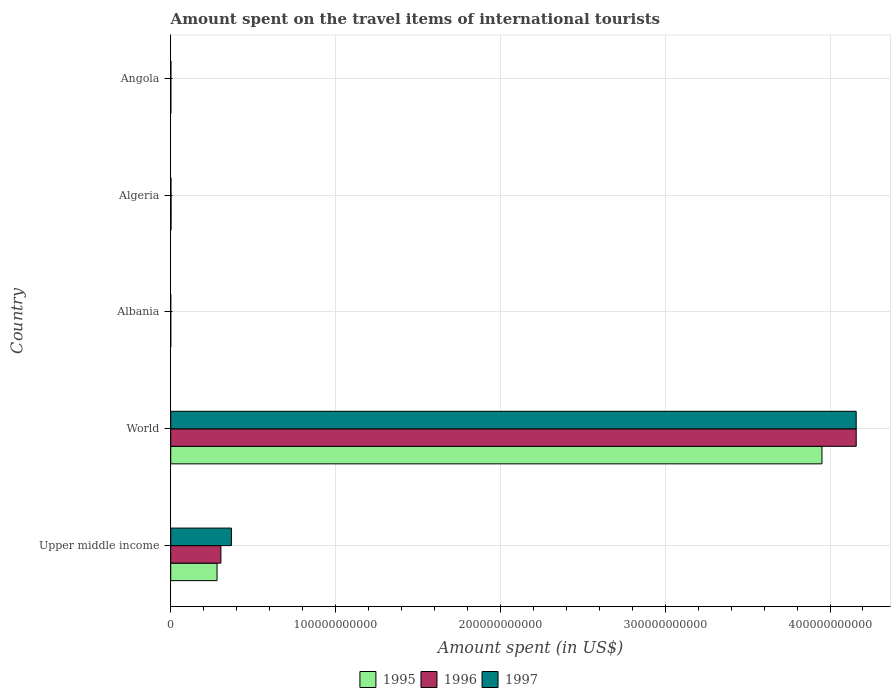Are the number of bars per tick equal to the number of legend labels?
Your answer should be compact. Yes. How many bars are there on the 3rd tick from the top?
Make the answer very short. 3. What is the label of the 3rd group of bars from the top?
Ensure brevity in your answer.  Albania. In how many cases, is the number of bars for a given country not equal to the number of legend labels?
Make the answer very short. 0. What is the amount spent on the travel items of international tourists in 1995 in Albania?
Your answer should be very brief. 7.00e+06. Across all countries, what is the maximum amount spent on the travel items of international tourists in 1995?
Your answer should be compact. 3.95e+11. Across all countries, what is the minimum amount spent on the travel items of international tourists in 1995?
Your response must be concise. 7.00e+06. In which country was the amount spent on the travel items of international tourists in 1996 minimum?
Offer a very short reply. Albania. What is the total amount spent on the travel items of international tourists in 1996 in the graph?
Your answer should be compact. 4.47e+11. What is the difference between the amount spent on the travel items of international tourists in 1996 in Upper middle income and that in World?
Provide a short and direct response. -3.85e+11. What is the difference between the amount spent on the travel items of international tourists in 1996 in Algeria and the amount spent on the travel items of international tourists in 1995 in Upper middle income?
Provide a short and direct response. -2.79e+1. What is the average amount spent on the travel items of international tourists in 1995 per country?
Offer a very short reply. 8.47e+1. What is the difference between the amount spent on the travel items of international tourists in 1996 and amount spent on the travel items of international tourists in 1995 in Algeria?
Your response must be concise. 2.00e+06. What is the ratio of the amount spent on the travel items of international tourists in 1995 in Algeria to that in Upper middle income?
Make the answer very short. 0.01. What is the difference between the highest and the second highest amount spent on the travel items of international tourists in 1996?
Offer a terse response. 3.85e+11. What is the difference between the highest and the lowest amount spent on the travel items of international tourists in 1997?
Your answer should be very brief. 4.16e+11. In how many countries, is the amount spent on the travel items of international tourists in 1995 greater than the average amount spent on the travel items of international tourists in 1995 taken over all countries?
Your answer should be very brief. 1. Is the sum of the amount spent on the travel items of international tourists in 1996 in Angola and World greater than the maximum amount spent on the travel items of international tourists in 1997 across all countries?
Provide a succinct answer. Yes. What does the 2nd bar from the top in Algeria represents?
Offer a very short reply. 1996. Are all the bars in the graph horizontal?
Make the answer very short. Yes. What is the difference between two consecutive major ticks on the X-axis?
Make the answer very short. 1.00e+11. Are the values on the major ticks of X-axis written in scientific E-notation?
Keep it short and to the point. No. Where does the legend appear in the graph?
Your answer should be very brief. Bottom center. How many legend labels are there?
Your response must be concise. 3. What is the title of the graph?
Offer a terse response. Amount spent on the travel items of international tourists. What is the label or title of the X-axis?
Provide a short and direct response. Amount spent (in US$). What is the label or title of the Y-axis?
Ensure brevity in your answer.  Country. What is the Amount spent (in US$) of 1995 in Upper middle income?
Offer a terse response. 2.81e+1. What is the Amount spent (in US$) of 1996 in Upper middle income?
Offer a terse response. 3.04e+1. What is the Amount spent (in US$) in 1997 in Upper middle income?
Keep it short and to the point. 3.68e+1. What is the Amount spent (in US$) in 1995 in World?
Your response must be concise. 3.95e+11. What is the Amount spent (in US$) in 1996 in World?
Ensure brevity in your answer.  4.16e+11. What is the Amount spent (in US$) of 1997 in World?
Ensure brevity in your answer.  4.16e+11. What is the Amount spent (in US$) in 1995 in Albania?
Offer a terse response. 7.00e+06. What is the Amount spent (in US$) in 1995 in Algeria?
Provide a succinct answer. 1.86e+08. What is the Amount spent (in US$) in 1996 in Algeria?
Offer a very short reply. 1.88e+08. What is the Amount spent (in US$) of 1997 in Algeria?
Your response must be concise. 1.44e+08. What is the Amount spent (in US$) of 1995 in Angola?
Offer a terse response. 7.50e+07. What is the Amount spent (in US$) of 1996 in Angola?
Provide a succinct answer. 7.30e+07. What is the Amount spent (in US$) of 1997 in Angola?
Offer a terse response. 9.80e+07. Across all countries, what is the maximum Amount spent (in US$) of 1995?
Offer a very short reply. 3.95e+11. Across all countries, what is the maximum Amount spent (in US$) in 1996?
Your answer should be very brief. 4.16e+11. Across all countries, what is the maximum Amount spent (in US$) in 1997?
Your answer should be compact. 4.16e+11. Across all countries, what is the minimum Amount spent (in US$) of 1995?
Keep it short and to the point. 7.00e+06. Across all countries, what is the minimum Amount spent (in US$) of 1996?
Your response must be concise. 1.20e+07. Across all countries, what is the minimum Amount spent (in US$) in 1997?
Provide a succinct answer. 5.00e+06. What is the total Amount spent (in US$) of 1995 in the graph?
Ensure brevity in your answer.  4.24e+11. What is the total Amount spent (in US$) of 1996 in the graph?
Your answer should be compact. 4.47e+11. What is the total Amount spent (in US$) of 1997 in the graph?
Your answer should be very brief. 4.53e+11. What is the difference between the Amount spent (in US$) in 1995 in Upper middle income and that in World?
Make the answer very short. -3.67e+11. What is the difference between the Amount spent (in US$) in 1996 in Upper middle income and that in World?
Offer a very short reply. -3.85e+11. What is the difference between the Amount spent (in US$) of 1997 in Upper middle income and that in World?
Provide a short and direct response. -3.79e+11. What is the difference between the Amount spent (in US$) of 1995 in Upper middle income and that in Albania?
Ensure brevity in your answer.  2.81e+1. What is the difference between the Amount spent (in US$) of 1996 in Upper middle income and that in Albania?
Your response must be concise. 3.04e+1. What is the difference between the Amount spent (in US$) in 1997 in Upper middle income and that in Albania?
Offer a very short reply. 3.68e+1. What is the difference between the Amount spent (in US$) in 1995 in Upper middle income and that in Algeria?
Make the answer very short. 2.79e+1. What is the difference between the Amount spent (in US$) in 1996 in Upper middle income and that in Algeria?
Offer a very short reply. 3.03e+1. What is the difference between the Amount spent (in US$) in 1997 in Upper middle income and that in Algeria?
Keep it short and to the point. 3.67e+1. What is the difference between the Amount spent (in US$) of 1995 in Upper middle income and that in Angola?
Keep it short and to the point. 2.80e+1. What is the difference between the Amount spent (in US$) of 1996 in Upper middle income and that in Angola?
Provide a short and direct response. 3.04e+1. What is the difference between the Amount spent (in US$) in 1997 in Upper middle income and that in Angola?
Ensure brevity in your answer.  3.67e+1. What is the difference between the Amount spent (in US$) in 1995 in World and that in Albania?
Your answer should be compact. 3.95e+11. What is the difference between the Amount spent (in US$) in 1996 in World and that in Albania?
Offer a very short reply. 4.16e+11. What is the difference between the Amount spent (in US$) in 1997 in World and that in Albania?
Offer a very short reply. 4.16e+11. What is the difference between the Amount spent (in US$) of 1995 in World and that in Algeria?
Your answer should be very brief. 3.95e+11. What is the difference between the Amount spent (in US$) of 1996 in World and that in Algeria?
Provide a succinct answer. 4.16e+11. What is the difference between the Amount spent (in US$) of 1997 in World and that in Algeria?
Offer a very short reply. 4.16e+11. What is the difference between the Amount spent (in US$) of 1995 in World and that in Angola?
Offer a very short reply. 3.95e+11. What is the difference between the Amount spent (in US$) of 1996 in World and that in Angola?
Ensure brevity in your answer.  4.16e+11. What is the difference between the Amount spent (in US$) of 1997 in World and that in Angola?
Provide a succinct answer. 4.16e+11. What is the difference between the Amount spent (in US$) in 1995 in Albania and that in Algeria?
Provide a succinct answer. -1.79e+08. What is the difference between the Amount spent (in US$) of 1996 in Albania and that in Algeria?
Provide a short and direct response. -1.76e+08. What is the difference between the Amount spent (in US$) of 1997 in Albania and that in Algeria?
Offer a terse response. -1.39e+08. What is the difference between the Amount spent (in US$) of 1995 in Albania and that in Angola?
Your response must be concise. -6.80e+07. What is the difference between the Amount spent (in US$) in 1996 in Albania and that in Angola?
Offer a very short reply. -6.10e+07. What is the difference between the Amount spent (in US$) in 1997 in Albania and that in Angola?
Give a very brief answer. -9.30e+07. What is the difference between the Amount spent (in US$) of 1995 in Algeria and that in Angola?
Keep it short and to the point. 1.11e+08. What is the difference between the Amount spent (in US$) in 1996 in Algeria and that in Angola?
Provide a succinct answer. 1.15e+08. What is the difference between the Amount spent (in US$) of 1997 in Algeria and that in Angola?
Provide a succinct answer. 4.60e+07. What is the difference between the Amount spent (in US$) of 1995 in Upper middle income and the Amount spent (in US$) of 1996 in World?
Ensure brevity in your answer.  -3.88e+11. What is the difference between the Amount spent (in US$) of 1995 in Upper middle income and the Amount spent (in US$) of 1997 in World?
Your response must be concise. -3.88e+11. What is the difference between the Amount spent (in US$) in 1996 in Upper middle income and the Amount spent (in US$) in 1997 in World?
Keep it short and to the point. -3.85e+11. What is the difference between the Amount spent (in US$) in 1995 in Upper middle income and the Amount spent (in US$) in 1996 in Albania?
Your response must be concise. 2.81e+1. What is the difference between the Amount spent (in US$) of 1995 in Upper middle income and the Amount spent (in US$) of 1997 in Albania?
Make the answer very short. 2.81e+1. What is the difference between the Amount spent (in US$) of 1996 in Upper middle income and the Amount spent (in US$) of 1997 in Albania?
Offer a very short reply. 3.04e+1. What is the difference between the Amount spent (in US$) in 1995 in Upper middle income and the Amount spent (in US$) in 1996 in Algeria?
Provide a succinct answer. 2.79e+1. What is the difference between the Amount spent (in US$) in 1995 in Upper middle income and the Amount spent (in US$) in 1997 in Algeria?
Give a very brief answer. 2.80e+1. What is the difference between the Amount spent (in US$) of 1996 in Upper middle income and the Amount spent (in US$) of 1997 in Algeria?
Your answer should be very brief. 3.03e+1. What is the difference between the Amount spent (in US$) in 1995 in Upper middle income and the Amount spent (in US$) in 1996 in Angola?
Give a very brief answer. 2.80e+1. What is the difference between the Amount spent (in US$) of 1995 in Upper middle income and the Amount spent (in US$) of 1997 in Angola?
Ensure brevity in your answer.  2.80e+1. What is the difference between the Amount spent (in US$) of 1996 in Upper middle income and the Amount spent (in US$) of 1997 in Angola?
Your answer should be very brief. 3.03e+1. What is the difference between the Amount spent (in US$) of 1995 in World and the Amount spent (in US$) of 1996 in Albania?
Your answer should be very brief. 3.95e+11. What is the difference between the Amount spent (in US$) in 1995 in World and the Amount spent (in US$) in 1997 in Albania?
Provide a short and direct response. 3.95e+11. What is the difference between the Amount spent (in US$) of 1996 in World and the Amount spent (in US$) of 1997 in Albania?
Provide a short and direct response. 4.16e+11. What is the difference between the Amount spent (in US$) of 1995 in World and the Amount spent (in US$) of 1996 in Algeria?
Ensure brevity in your answer.  3.95e+11. What is the difference between the Amount spent (in US$) of 1995 in World and the Amount spent (in US$) of 1997 in Algeria?
Your response must be concise. 3.95e+11. What is the difference between the Amount spent (in US$) in 1996 in World and the Amount spent (in US$) in 1997 in Algeria?
Ensure brevity in your answer.  4.16e+11. What is the difference between the Amount spent (in US$) in 1995 in World and the Amount spent (in US$) in 1996 in Angola?
Keep it short and to the point. 3.95e+11. What is the difference between the Amount spent (in US$) of 1995 in World and the Amount spent (in US$) of 1997 in Angola?
Ensure brevity in your answer.  3.95e+11. What is the difference between the Amount spent (in US$) of 1996 in World and the Amount spent (in US$) of 1997 in Angola?
Provide a short and direct response. 4.16e+11. What is the difference between the Amount spent (in US$) in 1995 in Albania and the Amount spent (in US$) in 1996 in Algeria?
Provide a short and direct response. -1.81e+08. What is the difference between the Amount spent (in US$) in 1995 in Albania and the Amount spent (in US$) in 1997 in Algeria?
Your answer should be compact. -1.37e+08. What is the difference between the Amount spent (in US$) of 1996 in Albania and the Amount spent (in US$) of 1997 in Algeria?
Your response must be concise. -1.32e+08. What is the difference between the Amount spent (in US$) of 1995 in Albania and the Amount spent (in US$) of 1996 in Angola?
Offer a very short reply. -6.60e+07. What is the difference between the Amount spent (in US$) of 1995 in Albania and the Amount spent (in US$) of 1997 in Angola?
Your answer should be compact. -9.10e+07. What is the difference between the Amount spent (in US$) in 1996 in Albania and the Amount spent (in US$) in 1997 in Angola?
Keep it short and to the point. -8.60e+07. What is the difference between the Amount spent (in US$) of 1995 in Algeria and the Amount spent (in US$) of 1996 in Angola?
Keep it short and to the point. 1.13e+08. What is the difference between the Amount spent (in US$) of 1995 in Algeria and the Amount spent (in US$) of 1997 in Angola?
Your answer should be compact. 8.80e+07. What is the difference between the Amount spent (in US$) of 1996 in Algeria and the Amount spent (in US$) of 1997 in Angola?
Offer a very short reply. 9.00e+07. What is the average Amount spent (in US$) of 1995 per country?
Offer a terse response. 8.47e+1. What is the average Amount spent (in US$) of 1996 per country?
Your answer should be compact. 8.93e+1. What is the average Amount spent (in US$) in 1997 per country?
Keep it short and to the point. 9.06e+1. What is the difference between the Amount spent (in US$) of 1995 and Amount spent (in US$) of 1996 in Upper middle income?
Offer a very short reply. -2.34e+09. What is the difference between the Amount spent (in US$) of 1995 and Amount spent (in US$) of 1997 in Upper middle income?
Your answer should be compact. -8.72e+09. What is the difference between the Amount spent (in US$) of 1996 and Amount spent (in US$) of 1997 in Upper middle income?
Give a very brief answer. -6.39e+09. What is the difference between the Amount spent (in US$) of 1995 and Amount spent (in US$) of 1996 in World?
Provide a succinct answer. -2.08e+1. What is the difference between the Amount spent (in US$) of 1995 and Amount spent (in US$) of 1997 in World?
Make the answer very short. -2.08e+1. What is the difference between the Amount spent (in US$) in 1996 and Amount spent (in US$) in 1997 in World?
Your answer should be very brief. 1.91e+07. What is the difference between the Amount spent (in US$) of 1995 and Amount spent (in US$) of 1996 in Albania?
Offer a very short reply. -5.00e+06. What is the difference between the Amount spent (in US$) of 1995 and Amount spent (in US$) of 1997 in Albania?
Offer a terse response. 2.00e+06. What is the difference between the Amount spent (in US$) of 1996 and Amount spent (in US$) of 1997 in Albania?
Keep it short and to the point. 7.00e+06. What is the difference between the Amount spent (in US$) in 1995 and Amount spent (in US$) in 1997 in Algeria?
Keep it short and to the point. 4.20e+07. What is the difference between the Amount spent (in US$) in 1996 and Amount spent (in US$) in 1997 in Algeria?
Offer a terse response. 4.40e+07. What is the difference between the Amount spent (in US$) of 1995 and Amount spent (in US$) of 1996 in Angola?
Make the answer very short. 2.00e+06. What is the difference between the Amount spent (in US$) in 1995 and Amount spent (in US$) in 1997 in Angola?
Your answer should be very brief. -2.30e+07. What is the difference between the Amount spent (in US$) in 1996 and Amount spent (in US$) in 1997 in Angola?
Offer a terse response. -2.50e+07. What is the ratio of the Amount spent (in US$) in 1995 in Upper middle income to that in World?
Keep it short and to the point. 0.07. What is the ratio of the Amount spent (in US$) of 1996 in Upper middle income to that in World?
Give a very brief answer. 0.07. What is the ratio of the Amount spent (in US$) in 1997 in Upper middle income to that in World?
Keep it short and to the point. 0.09. What is the ratio of the Amount spent (in US$) of 1995 in Upper middle income to that in Albania?
Provide a succinct answer. 4015.88. What is the ratio of the Amount spent (in US$) of 1996 in Upper middle income to that in Albania?
Offer a terse response. 2537.19. What is the ratio of the Amount spent (in US$) in 1997 in Upper middle income to that in Albania?
Your response must be concise. 7367.01. What is the ratio of the Amount spent (in US$) in 1995 in Upper middle income to that in Algeria?
Ensure brevity in your answer.  151.14. What is the ratio of the Amount spent (in US$) of 1996 in Upper middle income to that in Algeria?
Give a very brief answer. 161.95. What is the ratio of the Amount spent (in US$) in 1997 in Upper middle income to that in Algeria?
Keep it short and to the point. 255.8. What is the ratio of the Amount spent (in US$) in 1995 in Upper middle income to that in Angola?
Offer a terse response. 374.82. What is the ratio of the Amount spent (in US$) in 1996 in Upper middle income to that in Angola?
Keep it short and to the point. 417.07. What is the ratio of the Amount spent (in US$) of 1997 in Upper middle income to that in Angola?
Make the answer very short. 375.87. What is the ratio of the Amount spent (in US$) of 1995 in World to that in Albania?
Provide a short and direct response. 5.64e+04. What is the ratio of the Amount spent (in US$) of 1996 in World to that in Albania?
Offer a very short reply. 3.47e+04. What is the ratio of the Amount spent (in US$) in 1997 in World to that in Albania?
Your response must be concise. 8.32e+04. What is the ratio of the Amount spent (in US$) of 1995 in World to that in Algeria?
Your answer should be very brief. 2124.35. What is the ratio of the Amount spent (in US$) of 1996 in World to that in Algeria?
Your answer should be very brief. 2212.28. What is the ratio of the Amount spent (in US$) of 1997 in World to that in Algeria?
Your answer should be compact. 2888.12. What is the ratio of the Amount spent (in US$) in 1995 in World to that in Angola?
Your answer should be very brief. 5268.38. What is the ratio of the Amount spent (in US$) of 1996 in World to that in Angola?
Your answer should be very brief. 5697.38. What is the ratio of the Amount spent (in US$) of 1997 in World to that in Angola?
Offer a very short reply. 4243.77. What is the ratio of the Amount spent (in US$) of 1995 in Albania to that in Algeria?
Provide a succinct answer. 0.04. What is the ratio of the Amount spent (in US$) in 1996 in Albania to that in Algeria?
Your response must be concise. 0.06. What is the ratio of the Amount spent (in US$) in 1997 in Albania to that in Algeria?
Make the answer very short. 0.03. What is the ratio of the Amount spent (in US$) of 1995 in Albania to that in Angola?
Provide a succinct answer. 0.09. What is the ratio of the Amount spent (in US$) of 1996 in Albania to that in Angola?
Offer a very short reply. 0.16. What is the ratio of the Amount spent (in US$) of 1997 in Albania to that in Angola?
Offer a very short reply. 0.05. What is the ratio of the Amount spent (in US$) of 1995 in Algeria to that in Angola?
Offer a terse response. 2.48. What is the ratio of the Amount spent (in US$) of 1996 in Algeria to that in Angola?
Your answer should be compact. 2.58. What is the ratio of the Amount spent (in US$) in 1997 in Algeria to that in Angola?
Give a very brief answer. 1.47. What is the difference between the highest and the second highest Amount spent (in US$) in 1995?
Offer a very short reply. 3.67e+11. What is the difference between the highest and the second highest Amount spent (in US$) of 1996?
Ensure brevity in your answer.  3.85e+11. What is the difference between the highest and the second highest Amount spent (in US$) in 1997?
Make the answer very short. 3.79e+11. What is the difference between the highest and the lowest Amount spent (in US$) of 1995?
Your response must be concise. 3.95e+11. What is the difference between the highest and the lowest Amount spent (in US$) of 1996?
Provide a succinct answer. 4.16e+11. What is the difference between the highest and the lowest Amount spent (in US$) in 1997?
Offer a very short reply. 4.16e+11. 